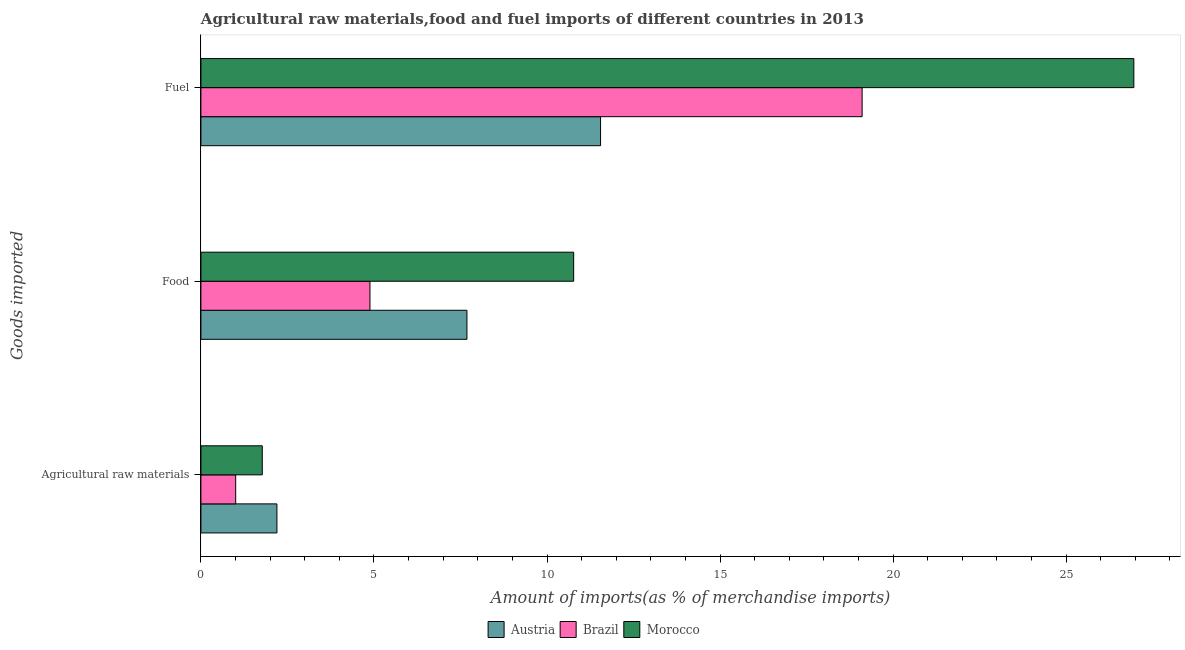How many bars are there on the 3rd tick from the top?
Your answer should be compact. 3. What is the label of the 3rd group of bars from the top?
Your answer should be very brief. Agricultural raw materials. What is the percentage of fuel imports in Austria?
Offer a very short reply. 11.55. Across all countries, what is the maximum percentage of raw materials imports?
Your response must be concise. 2.2. Across all countries, what is the minimum percentage of raw materials imports?
Provide a succinct answer. 1. In which country was the percentage of raw materials imports maximum?
Your answer should be very brief. Austria. What is the total percentage of raw materials imports in the graph?
Keep it short and to the point. 4.97. What is the difference between the percentage of food imports in Morocco and that in Austria?
Your answer should be very brief. 3.08. What is the difference between the percentage of raw materials imports in Brazil and the percentage of fuel imports in Austria?
Ensure brevity in your answer.  -10.54. What is the average percentage of raw materials imports per country?
Your response must be concise. 1.66. What is the difference between the percentage of food imports and percentage of raw materials imports in Brazil?
Your answer should be compact. 3.88. What is the ratio of the percentage of food imports in Austria to that in Brazil?
Provide a short and direct response. 1.57. What is the difference between the highest and the second highest percentage of fuel imports?
Keep it short and to the point. 7.85. What is the difference between the highest and the lowest percentage of fuel imports?
Offer a very short reply. 15.41. Is the sum of the percentage of food imports in Austria and Brazil greater than the maximum percentage of raw materials imports across all countries?
Your response must be concise. Yes. What does the 1st bar from the top in Food represents?
Provide a short and direct response. Morocco. What does the 3rd bar from the bottom in Food represents?
Make the answer very short. Morocco. How many bars are there?
Give a very brief answer. 9. Are all the bars in the graph horizontal?
Your answer should be compact. Yes. Does the graph contain any zero values?
Offer a terse response. No. How many legend labels are there?
Your answer should be compact. 3. What is the title of the graph?
Keep it short and to the point. Agricultural raw materials,food and fuel imports of different countries in 2013. Does "Brunei Darussalam" appear as one of the legend labels in the graph?
Offer a terse response. No. What is the label or title of the X-axis?
Give a very brief answer. Amount of imports(as % of merchandise imports). What is the label or title of the Y-axis?
Keep it short and to the point. Goods imported. What is the Amount of imports(as % of merchandise imports) of Austria in Agricultural raw materials?
Your response must be concise. 2.2. What is the Amount of imports(as % of merchandise imports) of Brazil in Agricultural raw materials?
Your answer should be very brief. 1. What is the Amount of imports(as % of merchandise imports) in Morocco in Agricultural raw materials?
Your response must be concise. 1.77. What is the Amount of imports(as % of merchandise imports) in Austria in Food?
Provide a short and direct response. 7.69. What is the Amount of imports(as % of merchandise imports) in Brazil in Food?
Your answer should be compact. 4.88. What is the Amount of imports(as % of merchandise imports) of Morocco in Food?
Provide a succinct answer. 10.77. What is the Amount of imports(as % of merchandise imports) in Austria in Fuel?
Ensure brevity in your answer.  11.55. What is the Amount of imports(as % of merchandise imports) of Brazil in Fuel?
Provide a short and direct response. 19.1. What is the Amount of imports(as % of merchandise imports) of Morocco in Fuel?
Give a very brief answer. 26.96. Across all Goods imported, what is the maximum Amount of imports(as % of merchandise imports) of Austria?
Make the answer very short. 11.55. Across all Goods imported, what is the maximum Amount of imports(as % of merchandise imports) in Brazil?
Provide a short and direct response. 19.1. Across all Goods imported, what is the maximum Amount of imports(as % of merchandise imports) of Morocco?
Your answer should be very brief. 26.96. Across all Goods imported, what is the minimum Amount of imports(as % of merchandise imports) of Austria?
Offer a terse response. 2.2. Across all Goods imported, what is the minimum Amount of imports(as % of merchandise imports) of Brazil?
Offer a very short reply. 1. Across all Goods imported, what is the minimum Amount of imports(as % of merchandise imports) of Morocco?
Offer a very short reply. 1.77. What is the total Amount of imports(as % of merchandise imports) in Austria in the graph?
Give a very brief answer. 21.43. What is the total Amount of imports(as % of merchandise imports) in Brazil in the graph?
Give a very brief answer. 24.99. What is the total Amount of imports(as % of merchandise imports) in Morocco in the graph?
Ensure brevity in your answer.  39.5. What is the difference between the Amount of imports(as % of merchandise imports) in Austria in Agricultural raw materials and that in Food?
Your response must be concise. -5.49. What is the difference between the Amount of imports(as % of merchandise imports) of Brazil in Agricultural raw materials and that in Food?
Ensure brevity in your answer.  -3.88. What is the difference between the Amount of imports(as % of merchandise imports) in Morocco in Agricultural raw materials and that in Food?
Provide a succinct answer. -9. What is the difference between the Amount of imports(as % of merchandise imports) in Austria in Agricultural raw materials and that in Fuel?
Make the answer very short. -9.35. What is the difference between the Amount of imports(as % of merchandise imports) of Brazil in Agricultural raw materials and that in Fuel?
Keep it short and to the point. -18.1. What is the difference between the Amount of imports(as % of merchandise imports) in Morocco in Agricultural raw materials and that in Fuel?
Your answer should be very brief. -25.18. What is the difference between the Amount of imports(as % of merchandise imports) of Austria in Food and that in Fuel?
Offer a terse response. -3.86. What is the difference between the Amount of imports(as % of merchandise imports) of Brazil in Food and that in Fuel?
Your answer should be very brief. -14.22. What is the difference between the Amount of imports(as % of merchandise imports) of Morocco in Food and that in Fuel?
Keep it short and to the point. -16.19. What is the difference between the Amount of imports(as % of merchandise imports) of Austria in Agricultural raw materials and the Amount of imports(as % of merchandise imports) of Brazil in Food?
Give a very brief answer. -2.69. What is the difference between the Amount of imports(as % of merchandise imports) of Austria in Agricultural raw materials and the Amount of imports(as % of merchandise imports) of Morocco in Food?
Ensure brevity in your answer.  -8.57. What is the difference between the Amount of imports(as % of merchandise imports) in Brazil in Agricultural raw materials and the Amount of imports(as % of merchandise imports) in Morocco in Food?
Ensure brevity in your answer.  -9.77. What is the difference between the Amount of imports(as % of merchandise imports) of Austria in Agricultural raw materials and the Amount of imports(as % of merchandise imports) of Brazil in Fuel?
Make the answer very short. -16.91. What is the difference between the Amount of imports(as % of merchandise imports) of Austria in Agricultural raw materials and the Amount of imports(as % of merchandise imports) of Morocco in Fuel?
Offer a terse response. -24.76. What is the difference between the Amount of imports(as % of merchandise imports) of Brazil in Agricultural raw materials and the Amount of imports(as % of merchandise imports) of Morocco in Fuel?
Make the answer very short. -25.95. What is the difference between the Amount of imports(as % of merchandise imports) in Austria in Food and the Amount of imports(as % of merchandise imports) in Brazil in Fuel?
Keep it short and to the point. -11.42. What is the difference between the Amount of imports(as % of merchandise imports) in Austria in Food and the Amount of imports(as % of merchandise imports) in Morocco in Fuel?
Your response must be concise. -19.27. What is the difference between the Amount of imports(as % of merchandise imports) of Brazil in Food and the Amount of imports(as % of merchandise imports) of Morocco in Fuel?
Your answer should be compact. -22.07. What is the average Amount of imports(as % of merchandise imports) of Austria per Goods imported?
Provide a succinct answer. 7.14. What is the average Amount of imports(as % of merchandise imports) in Brazil per Goods imported?
Ensure brevity in your answer.  8.33. What is the average Amount of imports(as % of merchandise imports) in Morocco per Goods imported?
Your answer should be compact. 13.17. What is the difference between the Amount of imports(as % of merchandise imports) of Austria and Amount of imports(as % of merchandise imports) of Brazil in Agricultural raw materials?
Offer a very short reply. 1.19. What is the difference between the Amount of imports(as % of merchandise imports) in Austria and Amount of imports(as % of merchandise imports) in Morocco in Agricultural raw materials?
Ensure brevity in your answer.  0.42. What is the difference between the Amount of imports(as % of merchandise imports) of Brazil and Amount of imports(as % of merchandise imports) of Morocco in Agricultural raw materials?
Your answer should be very brief. -0.77. What is the difference between the Amount of imports(as % of merchandise imports) of Austria and Amount of imports(as % of merchandise imports) of Brazil in Food?
Give a very brief answer. 2.8. What is the difference between the Amount of imports(as % of merchandise imports) in Austria and Amount of imports(as % of merchandise imports) in Morocco in Food?
Provide a succinct answer. -3.08. What is the difference between the Amount of imports(as % of merchandise imports) of Brazil and Amount of imports(as % of merchandise imports) of Morocco in Food?
Make the answer very short. -5.89. What is the difference between the Amount of imports(as % of merchandise imports) of Austria and Amount of imports(as % of merchandise imports) of Brazil in Fuel?
Your answer should be very brief. -7.56. What is the difference between the Amount of imports(as % of merchandise imports) of Austria and Amount of imports(as % of merchandise imports) of Morocco in Fuel?
Ensure brevity in your answer.  -15.41. What is the difference between the Amount of imports(as % of merchandise imports) in Brazil and Amount of imports(as % of merchandise imports) in Morocco in Fuel?
Offer a terse response. -7.85. What is the ratio of the Amount of imports(as % of merchandise imports) of Austria in Agricultural raw materials to that in Food?
Provide a short and direct response. 0.29. What is the ratio of the Amount of imports(as % of merchandise imports) of Brazil in Agricultural raw materials to that in Food?
Make the answer very short. 0.21. What is the ratio of the Amount of imports(as % of merchandise imports) of Morocco in Agricultural raw materials to that in Food?
Your response must be concise. 0.16. What is the ratio of the Amount of imports(as % of merchandise imports) of Austria in Agricultural raw materials to that in Fuel?
Keep it short and to the point. 0.19. What is the ratio of the Amount of imports(as % of merchandise imports) in Brazil in Agricultural raw materials to that in Fuel?
Keep it short and to the point. 0.05. What is the ratio of the Amount of imports(as % of merchandise imports) of Morocco in Agricultural raw materials to that in Fuel?
Your answer should be compact. 0.07. What is the ratio of the Amount of imports(as % of merchandise imports) of Austria in Food to that in Fuel?
Keep it short and to the point. 0.67. What is the ratio of the Amount of imports(as % of merchandise imports) in Brazil in Food to that in Fuel?
Give a very brief answer. 0.26. What is the ratio of the Amount of imports(as % of merchandise imports) in Morocco in Food to that in Fuel?
Ensure brevity in your answer.  0.4. What is the difference between the highest and the second highest Amount of imports(as % of merchandise imports) of Austria?
Keep it short and to the point. 3.86. What is the difference between the highest and the second highest Amount of imports(as % of merchandise imports) in Brazil?
Your answer should be very brief. 14.22. What is the difference between the highest and the second highest Amount of imports(as % of merchandise imports) in Morocco?
Ensure brevity in your answer.  16.19. What is the difference between the highest and the lowest Amount of imports(as % of merchandise imports) of Austria?
Keep it short and to the point. 9.35. What is the difference between the highest and the lowest Amount of imports(as % of merchandise imports) in Brazil?
Offer a very short reply. 18.1. What is the difference between the highest and the lowest Amount of imports(as % of merchandise imports) of Morocco?
Give a very brief answer. 25.18. 